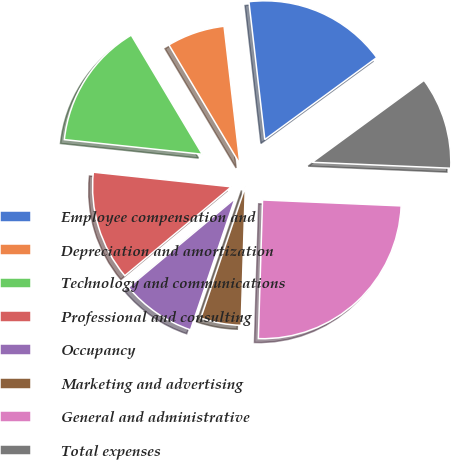<chart> <loc_0><loc_0><loc_500><loc_500><pie_chart><fcel>Employee compensation and<fcel>Depreciation and amortization<fcel>Technology and communications<fcel>Professional and consulting<fcel>Occupancy<fcel>Marketing and advertising<fcel>General and administrative<fcel>Total expenses<nl><fcel>16.77%<fcel>6.73%<fcel>14.76%<fcel>12.75%<fcel>8.73%<fcel>4.72%<fcel>24.8%<fcel>10.74%<nl></chart> 